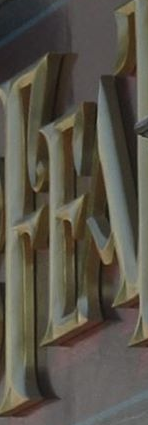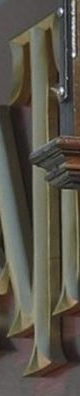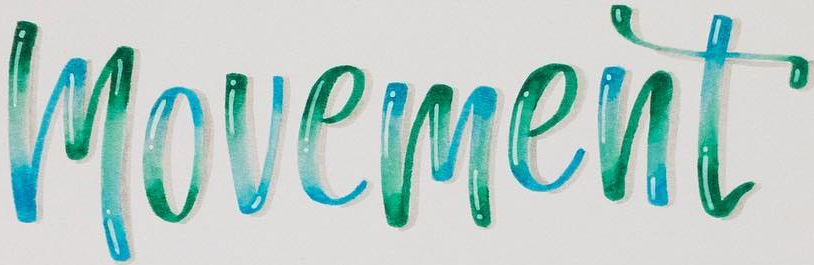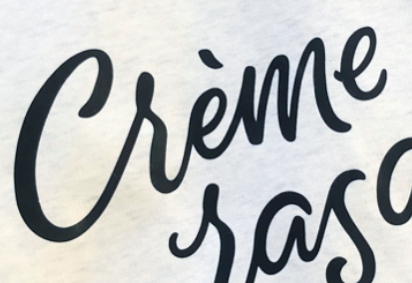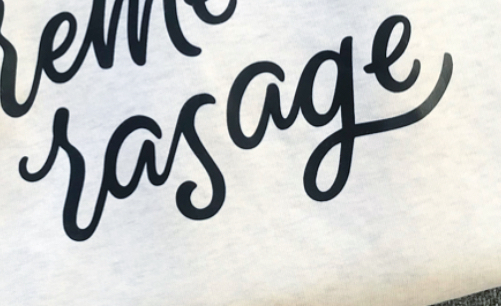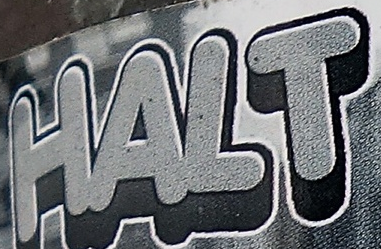Identify the words shown in these images in order, separated by a semicolon. FEA; T; movement; Crème; rasage; HALT 